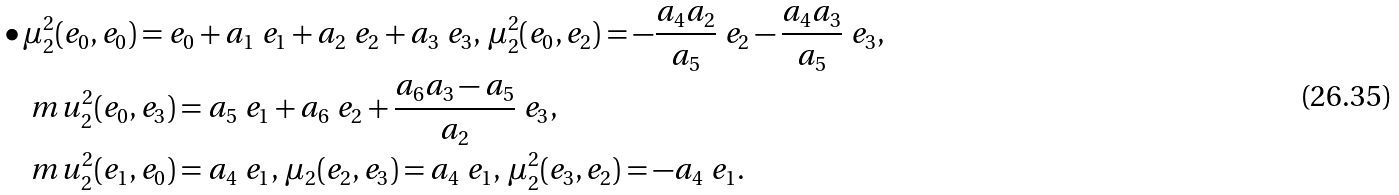Convert formula to latex. <formula><loc_0><loc_0><loc_500><loc_500>& \bullet \mu ^ { 2 } _ { 2 } ( e _ { 0 } , e _ { 0 } ) = e _ { 0 } + a _ { 1 } \ e _ { 1 } + a _ { 2 } \ e _ { 2 } + a _ { 3 } \ e _ { 3 } , \, \mu ^ { 2 } _ { 2 } ( e _ { 0 } , e _ { 2 } ) = - \frac { a _ { 4 } a _ { 2 } } { a _ { 5 } } \ e _ { 2 } - \frac { a _ { 4 } a _ { 3 } } { a _ { 5 } } \ e _ { 3 } , \, \\ & \quad m u ^ { 2 } _ { 2 } ( e _ { 0 } , e _ { 3 } ) = a _ { 5 } \ e _ { 1 } + a _ { 6 } \ e _ { 2 } + \frac { a _ { 6 } a _ { 3 } - a _ { 5 } } { a _ { 2 } } \ e _ { 3 } , \, \\ & \quad m u ^ { 2 } _ { 2 } ( e _ { 1 } , e _ { 0 } ) = a _ { 4 } \ e _ { 1 } , \, \mu _ { 2 } ( e _ { 2 } , e _ { 3 } ) = a _ { 4 } \ e _ { 1 } , \, \mu ^ { 2 } _ { 2 } ( e _ { 3 } , e _ { 2 } ) = - a _ { 4 } \ e _ { 1 } .</formula> 